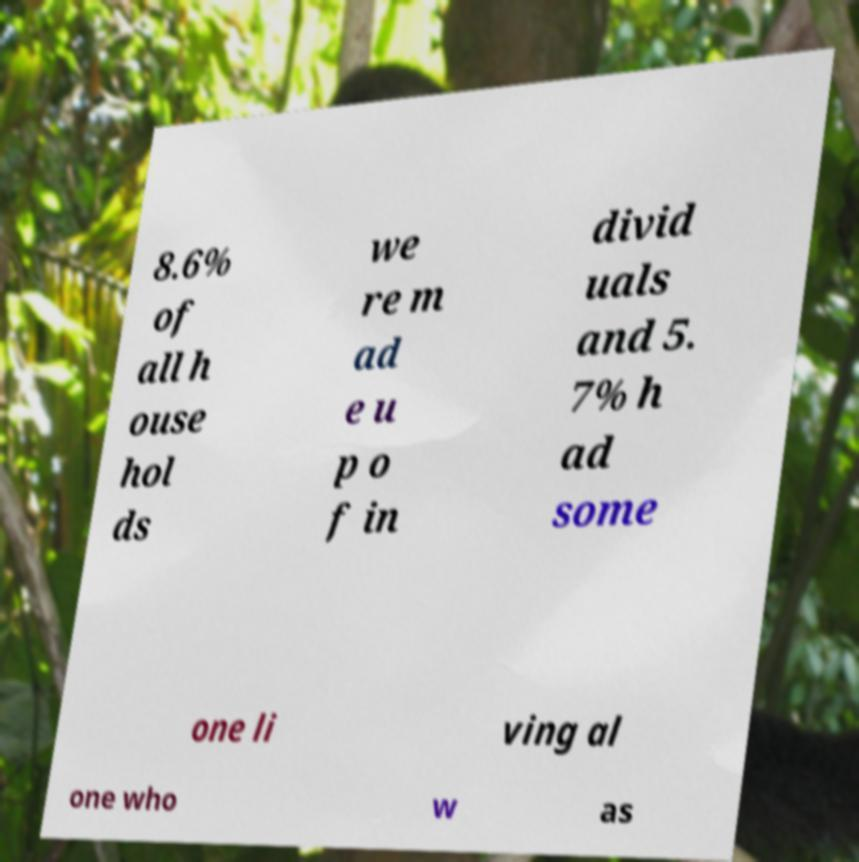Can you accurately transcribe the text from the provided image for me? 8.6% of all h ouse hol ds we re m ad e u p o f in divid uals and 5. 7% h ad some one li ving al one who w as 